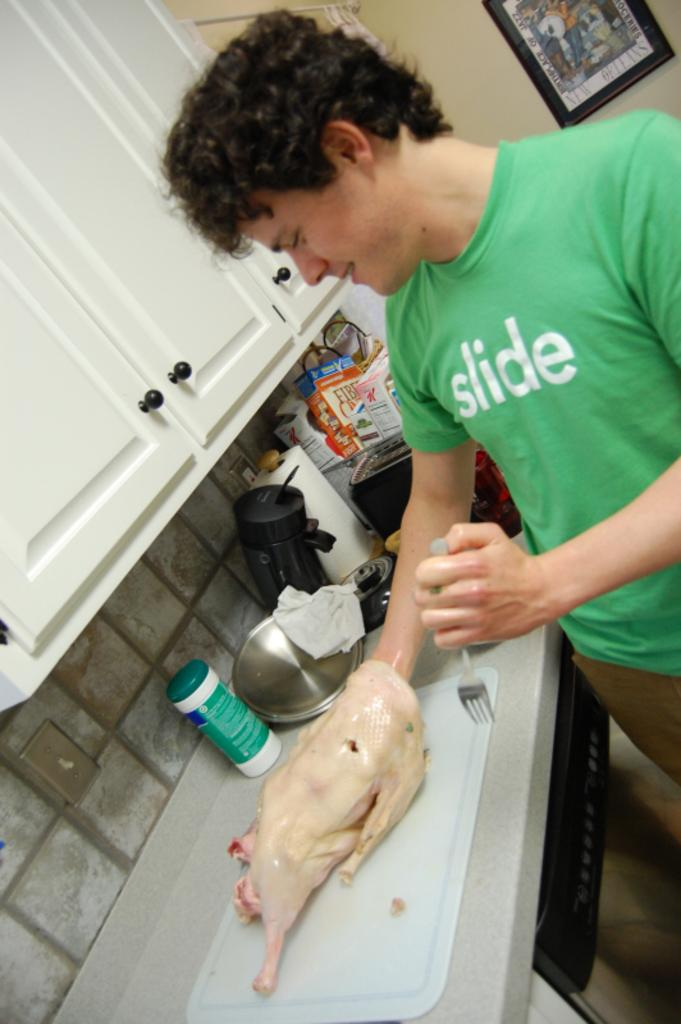<image>
Create a compact narrative representing the image presented. a boy wearing a green shirt that's labeled 'slide' 